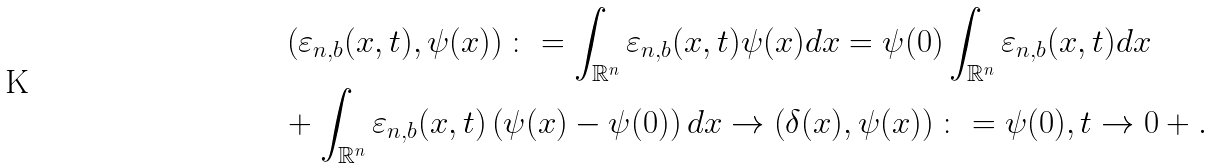Convert formula to latex. <formula><loc_0><loc_0><loc_500><loc_500>& \left ( \varepsilon _ { n , b } ( x , t ) , \psi ( x ) \right ) \colon = \int _ { \mathbb { R } ^ { n } } \varepsilon _ { n , b } ( x , t ) \psi ( x ) d x = \psi ( 0 ) \int _ { \mathbb { R } ^ { n } } \varepsilon _ { n , b } ( x , t ) d x \\ & + \int _ { \mathbb { R } ^ { n } } \varepsilon _ { n , b } ( x , t ) \left ( \psi ( x ) - \psi ( 0 ) \right ) d x \to \left ( \delta ( x ) , \psi ( x ) \right ) \colon = \psi ( 0 ) , t \to 0 + .</formula> 